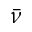<formula> <loc_0><loc_0><loc_500><loc_500>\bar { \nu }</formula> 